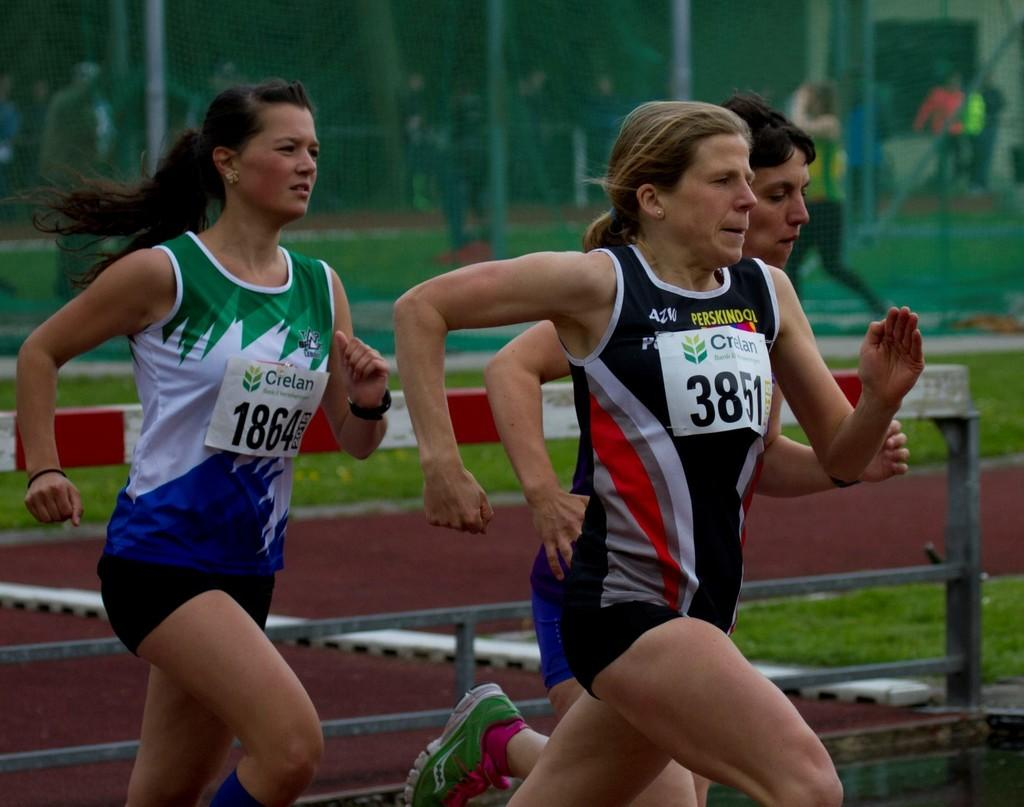<image>
Write a terse but informative summary of the picture. some fit women run wearing CIELAN numbered bibs 